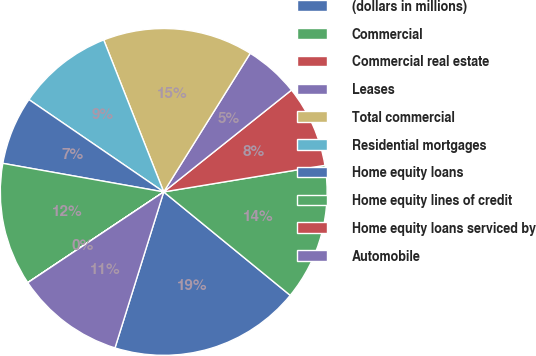<chart> <loc_0><loc_0><loc_500><loc_500><pie_chart><fcel>(dollars in millions)<fcel>Commercial<fcel>Commercial real estate<fcel>Leases<fcel>Total commercial<fcel>Residential mortgages<fcel>Home equity loans<fcel>Home equity lines of credit<fcel>Home equity loans serviced by<fcel>Automobile<nl><fcel>18.91%<fcel>13.51%<fcel>8.11%<fcel>5.41%<fcel>14.86%<fcel>9.46%<fcel>6.76%<fcel>12.16%<fcel>0.01%<fcel>10.81%<nl></chart> 